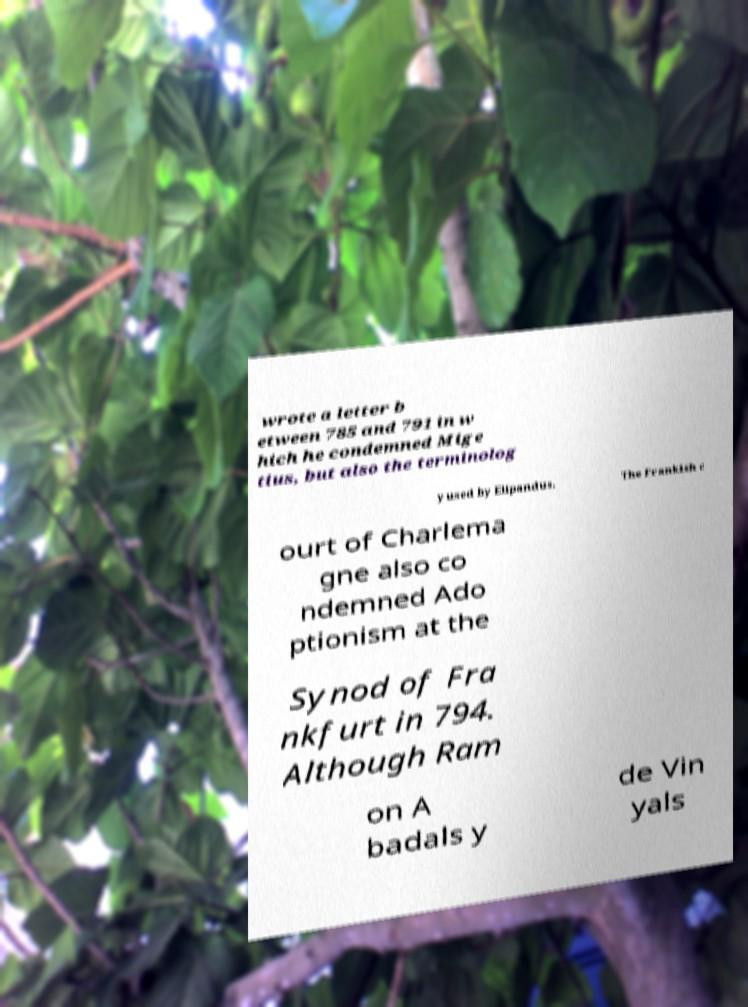Could you assist in decoding the text presented in this image and type it out clearly? wrote a letter b etween 785 and 791 in w hich he condemned Mige tius, but also the terminolog y used by Elipandus. The Frankish c ourt of Charlema gne also co ndemned Ado ptionism at the Synod of Fra nkfurt in 794. Although Ram on A badals y de Vin yals 